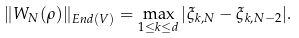<formula> <loc_0><loc_0><loc_500><loc_500>\| W _ { N } ( \rho ) \| _ { E n d ( V ) } = \max _ { 1 \leq k \leq d } | \xi _ { k , N } - \xi _ { k , N - 2 } | .</formula> 